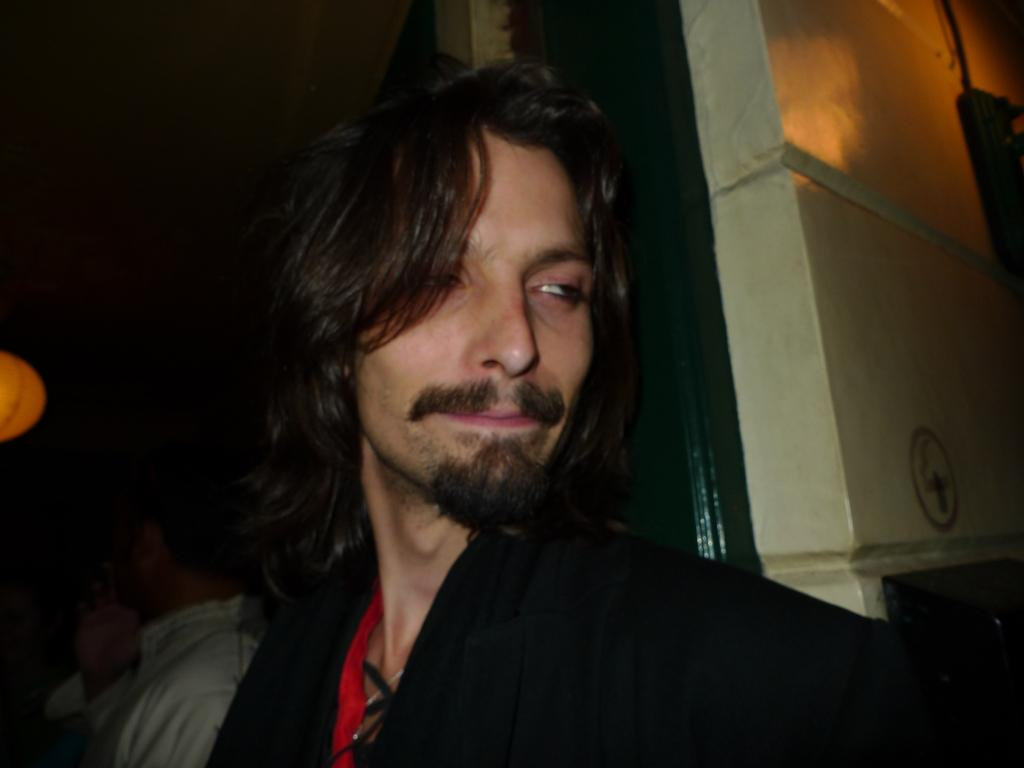Who is the main subject in the foreground of the image? There is a man in the foreground of the image. What can be seen in the background of the image? There are people in the background of the image, and the background is dark. What object is located on the left side of the image? There is a lantern on the left side of the image. What is the purpose of the wall in the image? The wall serves as a boundary or barrier in the image. What type of pest can be seen crawling on the ground in the image? There is no pest visible on the ground in the image. How many fangs does the man in the foreground have? The man in the foreground does not have any visible fangs, as he is a human and not a creature with fangs. 